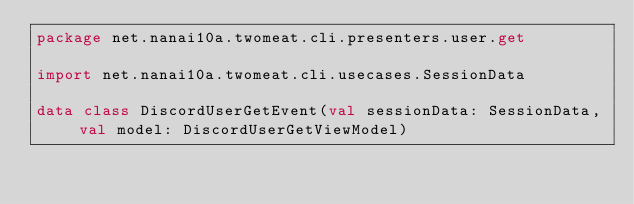Convert code to text. <code><loc_0><loc_0><loc_500><loc_500><_Kotlin_>package net.nanai10a.twomeat.cli.presenters.user.get

import net.nanai10a.twomeat.cli.usecases.SessionData

data class DiscordUserGetEvent(val sessionData: SessionData, val model: DiscordUserGetViewModel)
</code> 